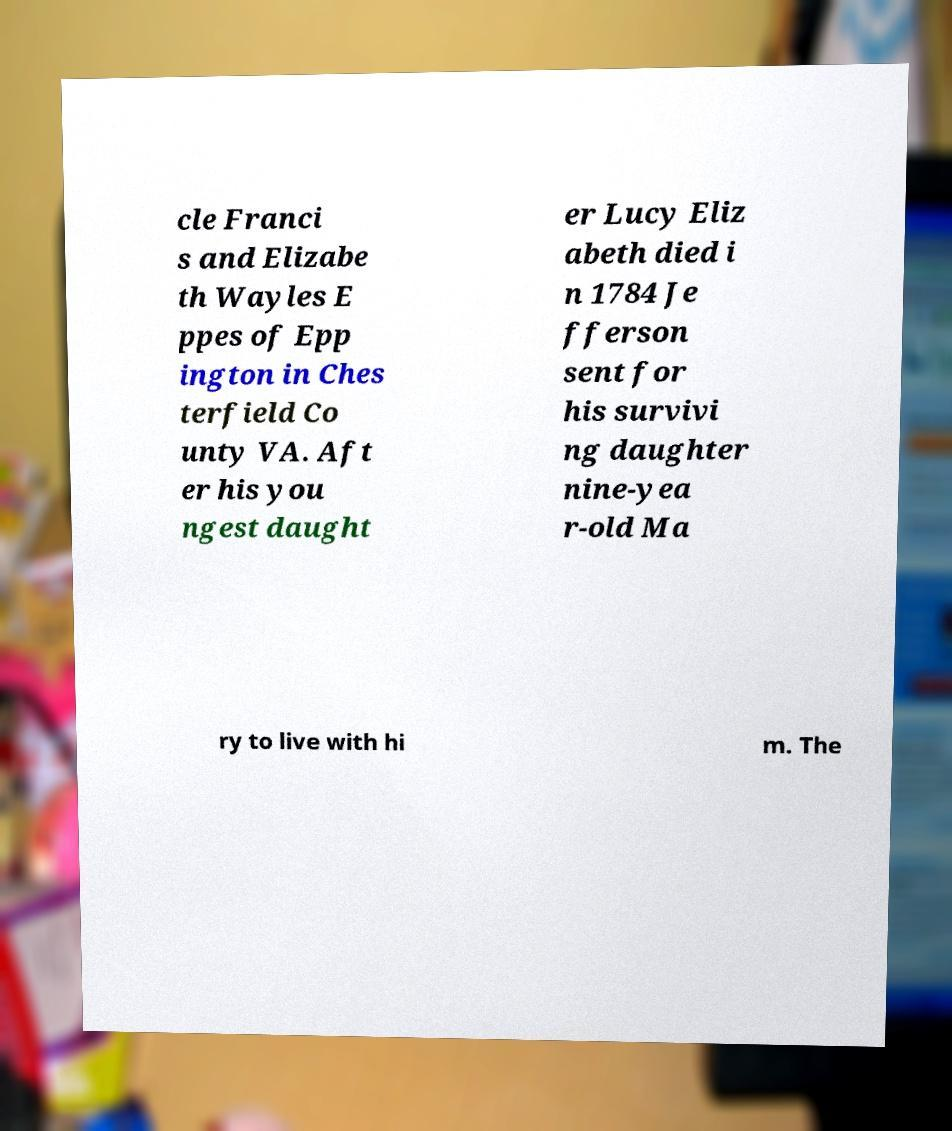Please read and relay the text visible in this image. What does it say? cle Franci s and Elizabe th Wayles E ppes of Epp ington in Ches terfield Co unty VA. Aft er his you ngest daught er Lucy Eliz abeth died i n 1784 Je fferson sent for his survivi ng daughter nine-yea r-old Ma ry to live with hi m. The 